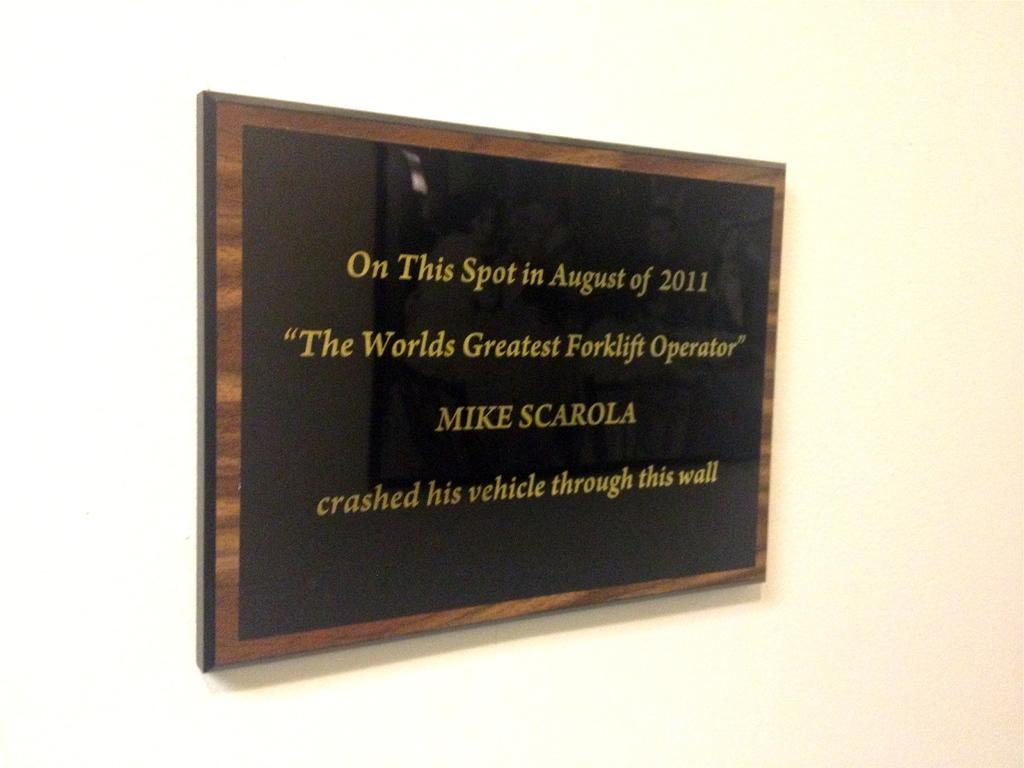<image>
Write a terse but informative summary of the picture. An award depicting a winner of a 2011 world's greatest forklift operator. 